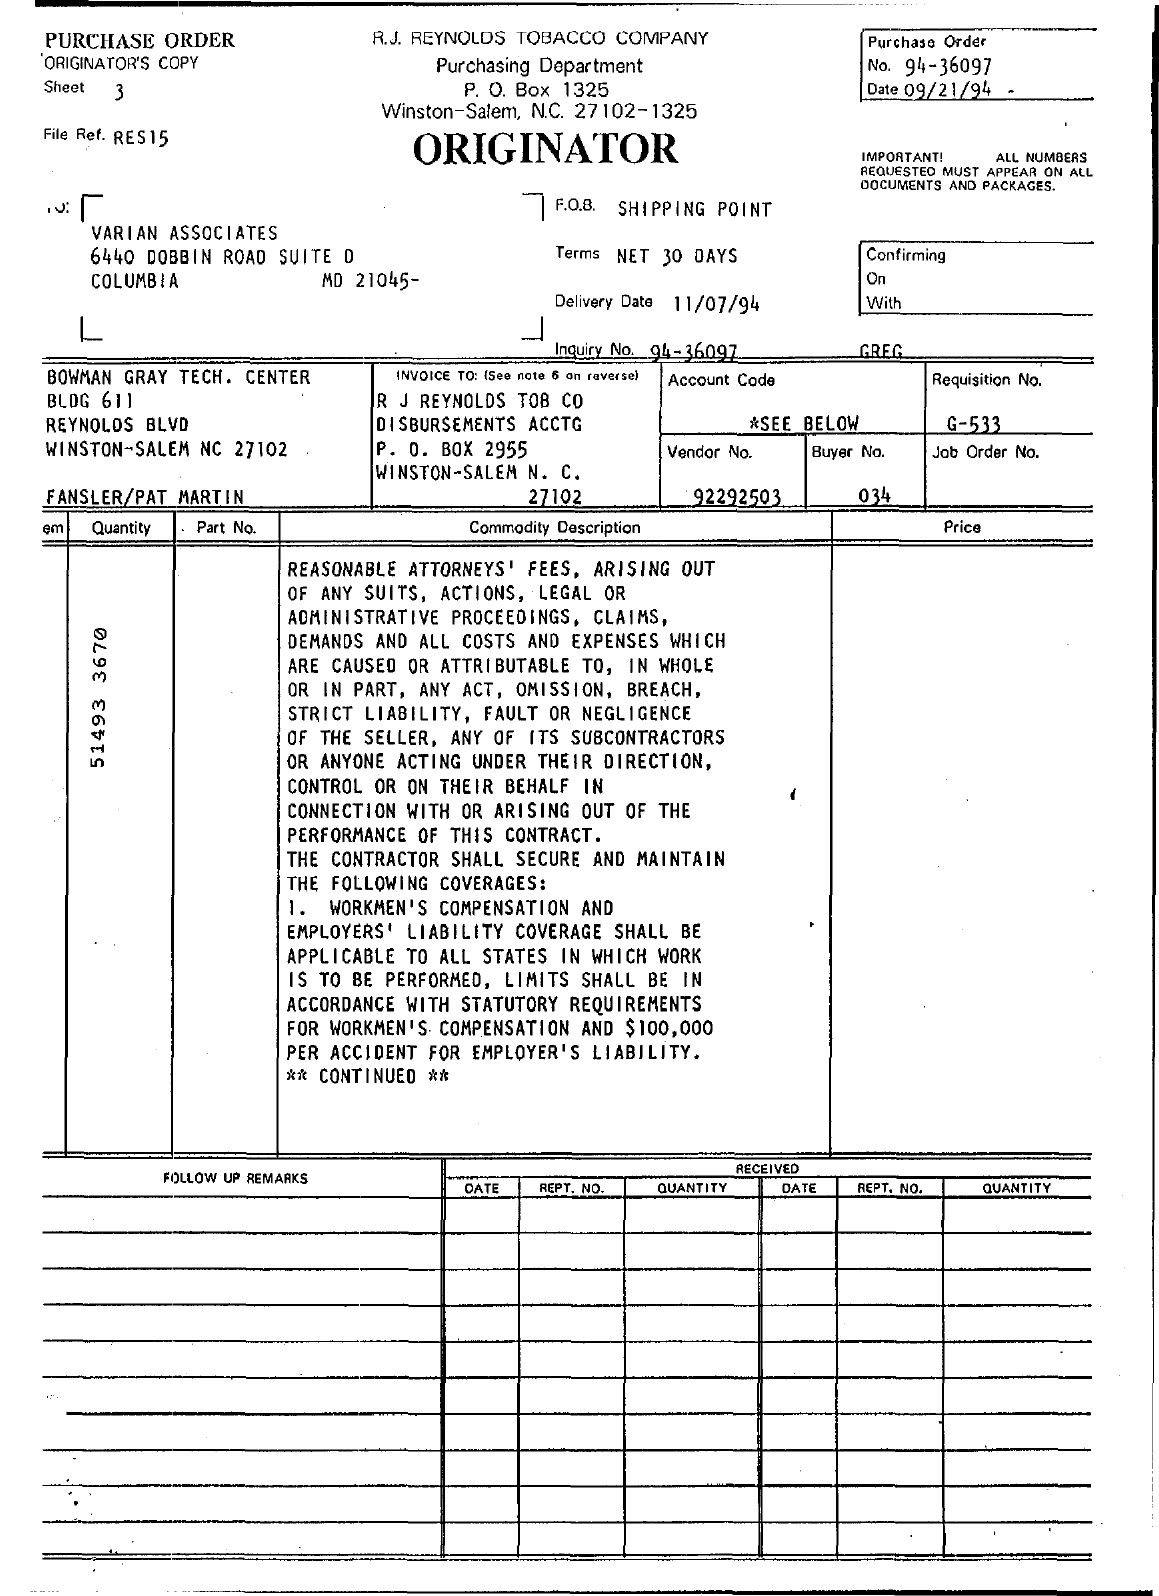What is the Purchase Order No.?
Your answer should be very brief. 94-36097. What is the Purchase Order Date?
Your answer should be very brief. 09/21/94. What is the Requisition No.?
Offer a terse response. G-533. What is the Buyer No.?
Offer a very short reply. 034. What is the Vendor No.?
Offer a terse response. 92292503. When is the Delivery Date?
Offer a very short reply. 11/07/94. 